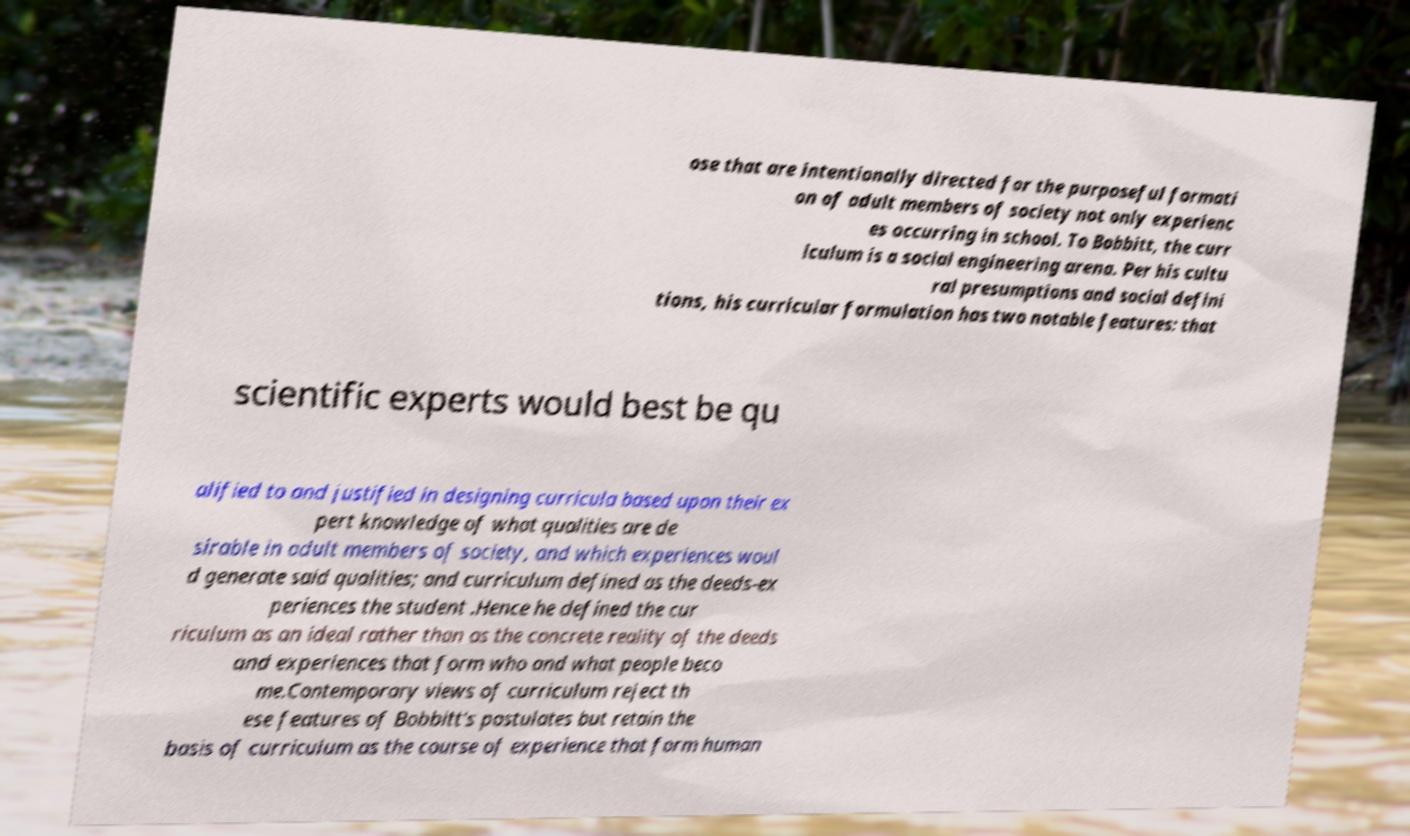There's text embedded in this image that I need extracted. Can you transcribe it verbatim? ose that are intentionally directed for the purposeful formati on of adult members of society not only experienc es occurring in school. To Bobbitt, the curr iculum is a social engineering arena. Per his cultu ral presumptions and social defini tions, his curricular formulation has two notable features: that scientific experts would best be qu alified to and justified in designing curricula based upon their ex pert knowledge of what qualities are de sirable in adult members of society, and which experiences woul d generate said qualities; and curriculum defined as the deeds-ex periences the student .Hence he defined the cur riculum as an ideal rather than as the concrete reality of the deeds and experiences that form who and what people beco me.Contemporary views of curriculum reject th ese features of Bobbitt's postulates but retain the basis of curriculum as the course of experience that form human 